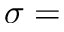Convert formula to latex. <formula><loc_0><loc_0><loc_500><loc_500>\sigma =</formula> 